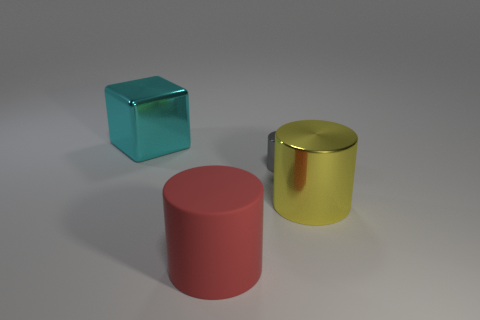Are there any large blue cylinders that have the same material as the small cylinder?
Keep it short and to the point. No. What shape is the thing that is both on the right side of the large matte object and behind the yellow object?
Keep it short and to the point. Cylinder. How many other things are there of the same shape as the large red rubber thing?
Offer a very short reply. 2. What is the size of the gray metallic cylinder?
Your answer should be very brief. Small. How many objects are big rubber things or big yellow metallic cylinders?
Give a very brief answer. 2. There is a cylinder that is left of the tiny gray cylinder; what is its size?
Your answer should be compact. Large. Are there any other things that are the same size as the gray thing?
Keep it short and to the point. No. What color is the big thing that is both left of the yellow cylinder and in front of the tiny thing?
Provide a succinct answer. Red. Is the large cylinder that is behind the red cylinder made of the same material as the gray cylinder?
Keep it short and to the point. Yes. There is a rubber thing; is it the same color as the big metal thing on the right side of the cyan metallic thing?
Offer a terse response. No. 